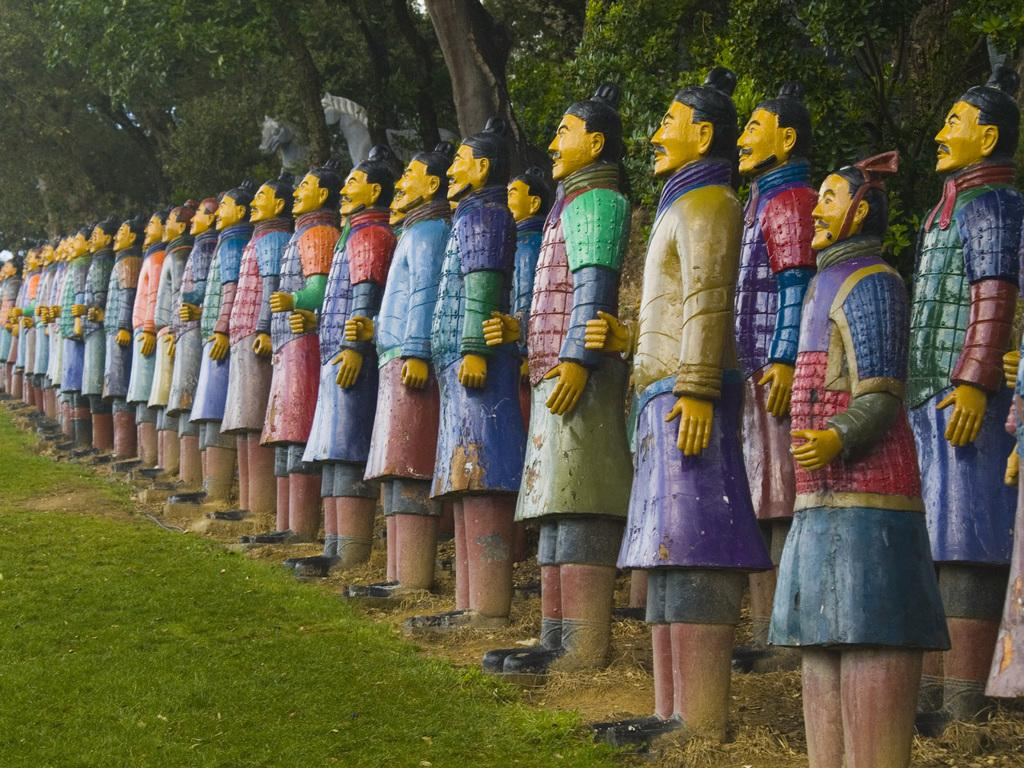What type of objects are depicted in the image? There are sculptures of men in the image. What type of natural environment is visible in the image? There is grass visible in the image. What can be seen in the background of the image? There are trees in the background of the image. Can you describe any other objects or features in the background of the image? There are other unspecified objects in the background of the image. What type of verse can be heard being recited by the sculptures in the image? There is no verse being recited by the sculptures in the image, as they are stationary objects and not capable of speech. 